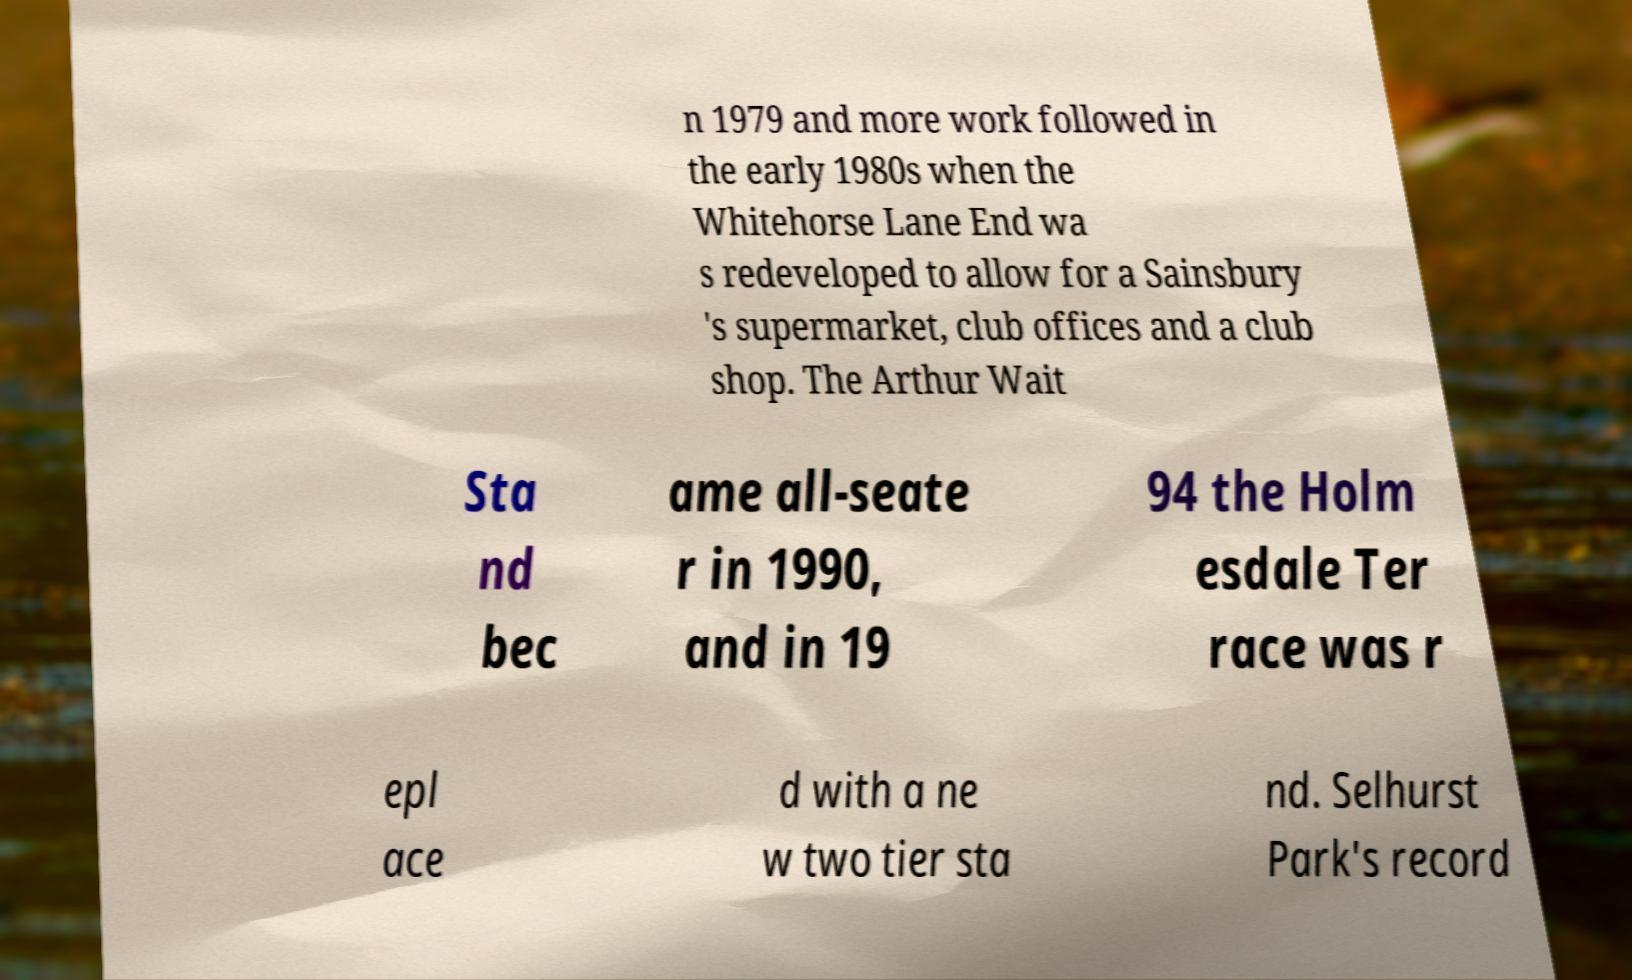What messages or text are displayed in this image? I need them in a readable, typed format. n 1979 and more work followed in the early 1980s when the Whitehorse Lane End wa s redeveloped to allow for a Sainsbury 's supermarket, club offices and a club shop. The Arthur Wait Sta nd bec ame all-seate r in 1990, and in 19 94 the Holm esdale Ter race was r epl ace d with a ne w two tier sta nd. Selhurst Park's record 